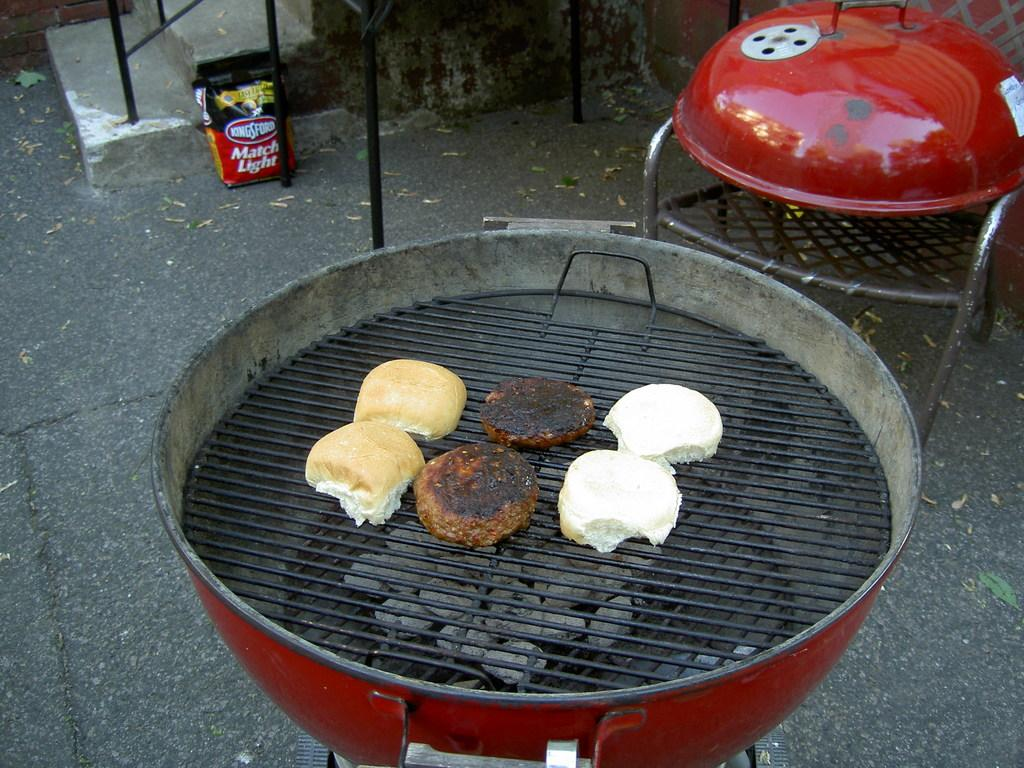<image>
Give a short and clear explanation of the subsequent image. A BBQ grill with buns and burgers on it and a bag of Kingsford match light in the background. 